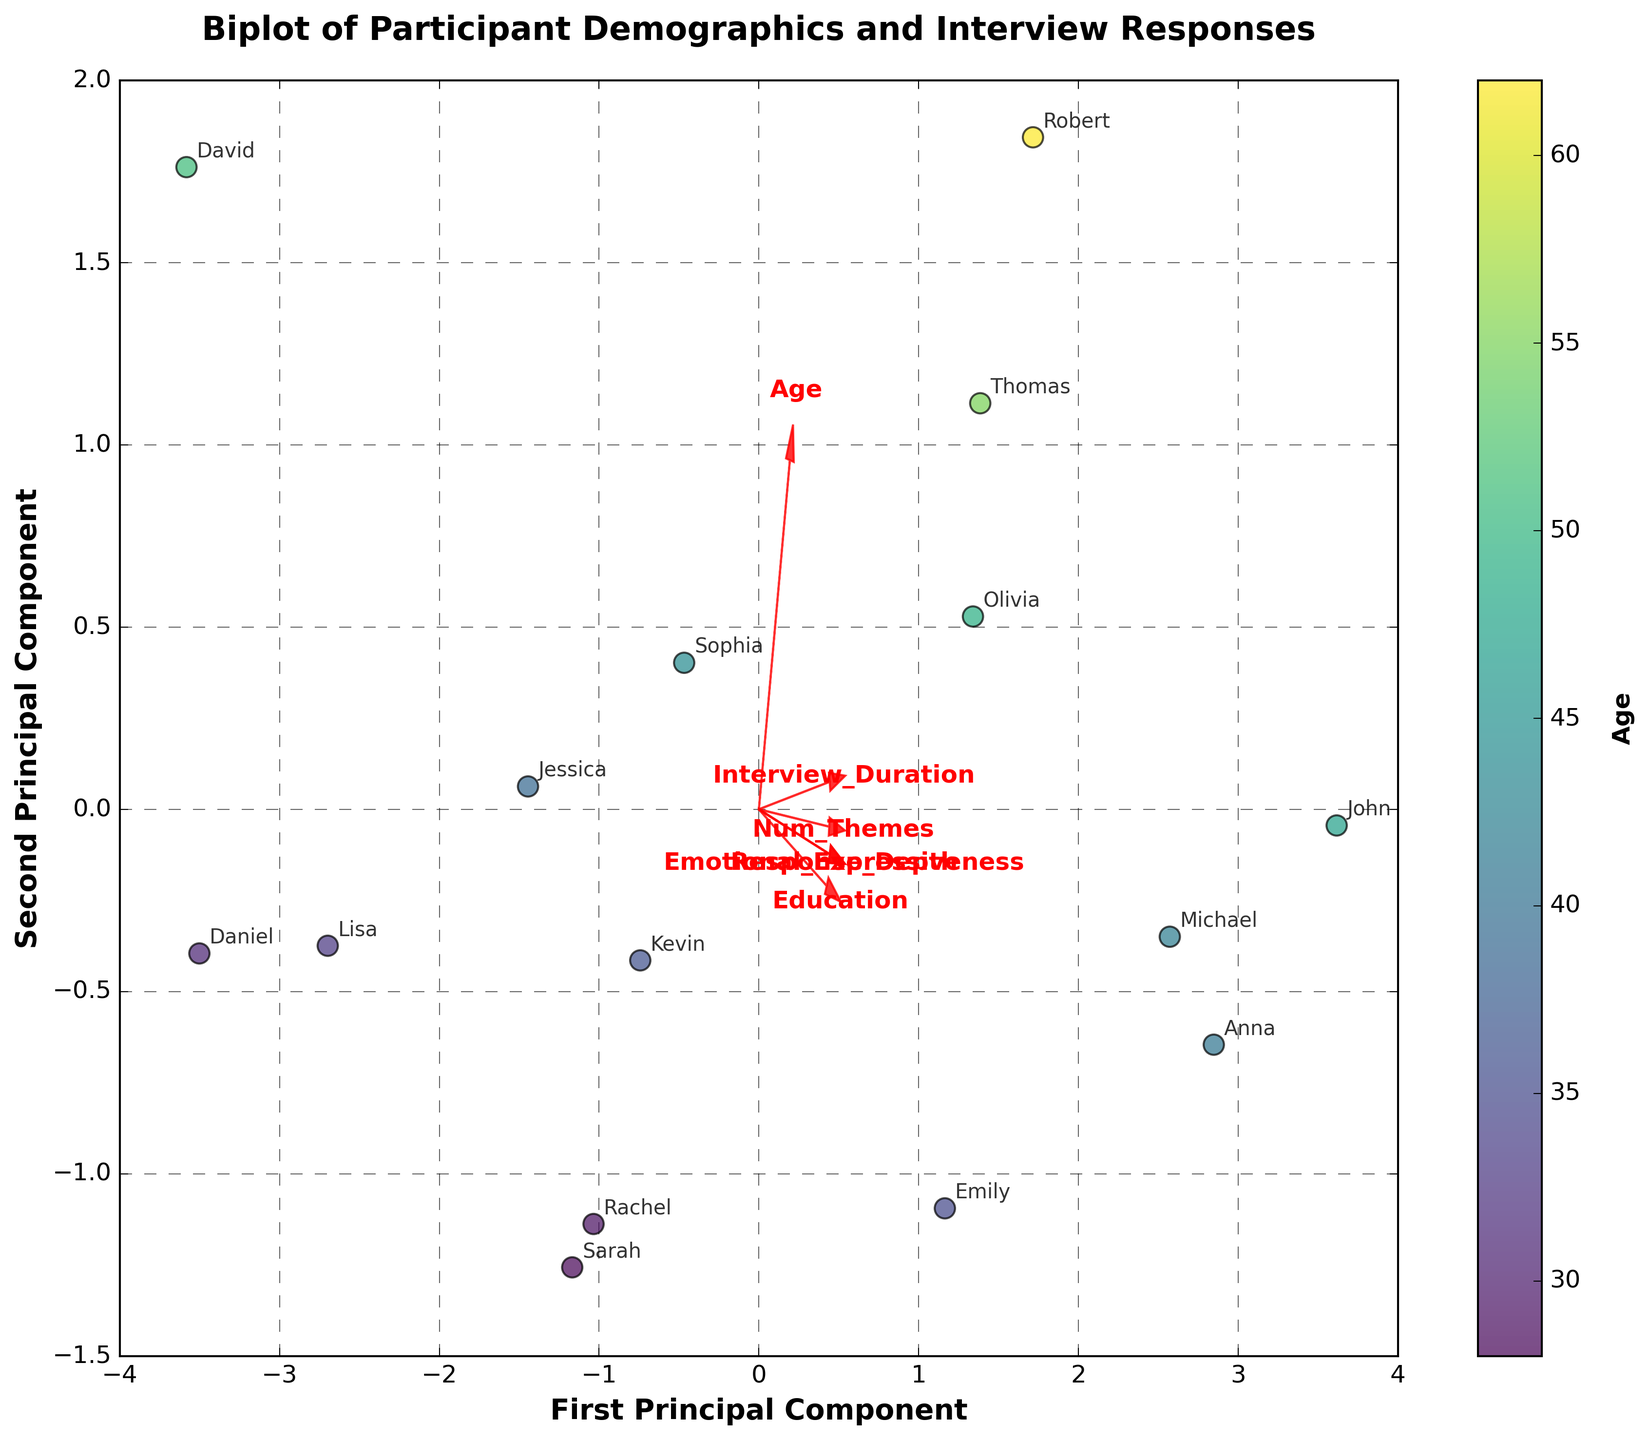What is the title of the plot? The title is located at the top of the plot and summarizes its content.
Answer: Biplot of Participant Demographics and Interview Responses How many participants are represented in the plot? The annotations on the plot show the number of participant names provided. Count each unique annotation to get the count.
Answer: 15 Which participant appears to have the highest value along the first principal component? Identify the participant farthest along the positive side of the first principal component (x-axis).
Answer: John Which feature vector has the longest arrow in the plot? By visually comparing the lengths of all red arrows representing the feature vectors, identify the longest one.
Answer: Age Are there any participants with the same coordinates on the biplot? Compare the positions of all participants. If any two or more have matching coordinates, they occupy the same point.
Answer: No What is the relationship between the 'Interview_Duration' feature and the second principal component? Check the direction of the 'Interview_Duration' arrow relative to the second principal component (y-axis).
Answer: Positive relationship Which two features are most similar in the plot based on the direction of their arrows? Look for feature vectors (arrows) that point in nearly the same direction.
Answer: Emotional_Expressiveness and Num_Themes Which participant is closest to the origin in the biplot? Identify the participant whose coordinates are nearest to (0,0) on the plot.
Answer: Daniel Is 'Education' more aligned with the first or the second principal component? Compare the direction of the 'Education' arrow with respect to the first and second principal components.
Answer: First principal component Which participant groups (by age) are on opposite sides of the first principal component? Observe the scatter points of different participants and see if younger (e.g., 28, 29) participants are on one side and older (e.g., 55, 62) participants are on the other.
Answer: Younger (e.g., Sarah, Rachel) vs. Older (e.g., Thomas, Robert) 